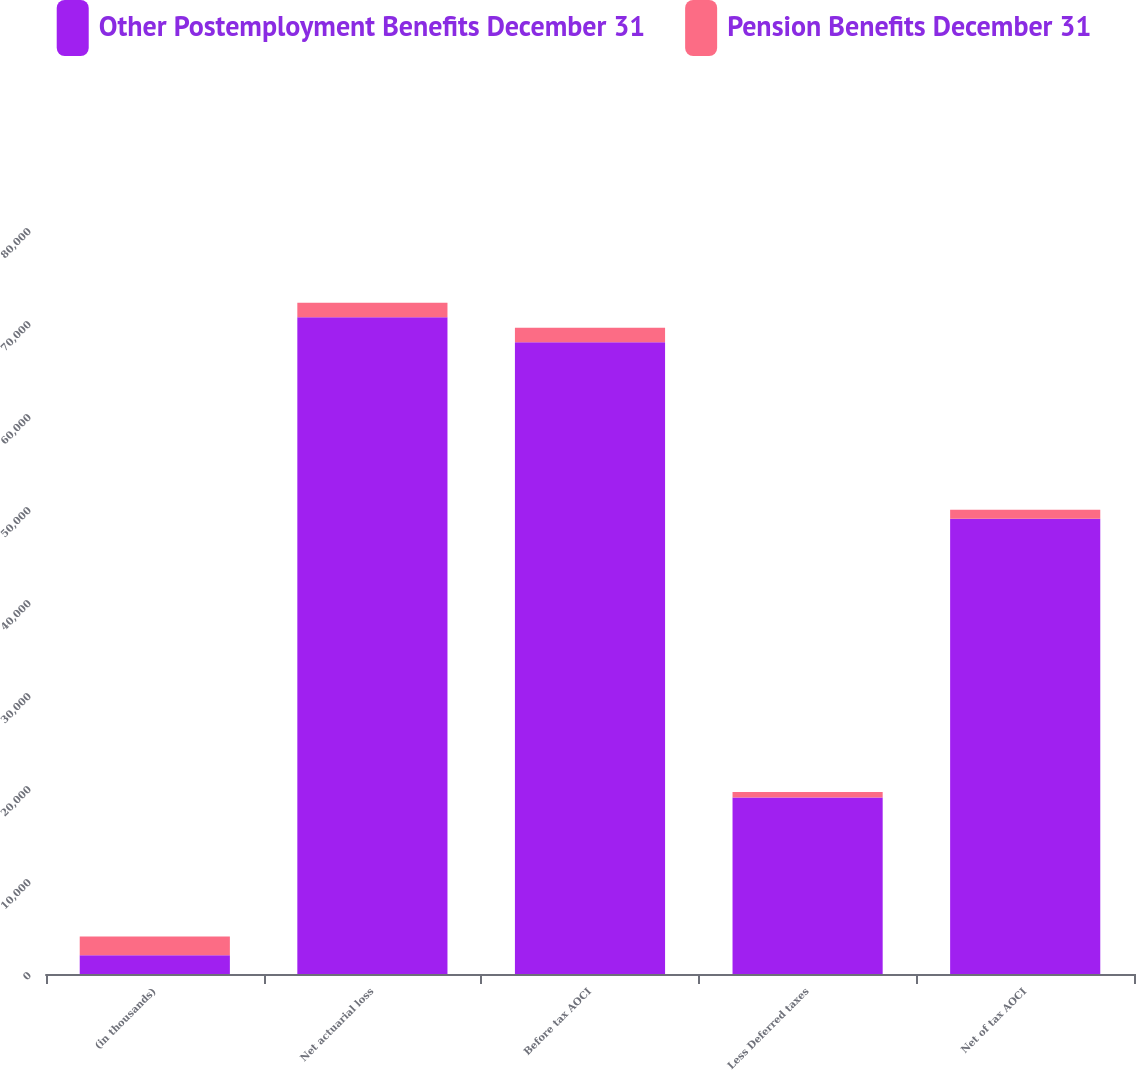Convert chart to OTSL. <chart><loc_0><loc_0><loc_500><loc_500><stacked_bar_chart><ecel><fcel>(in thousands)<fcel>Net actuarial loss<fcel>Before tax AOCI<fcel>Less Deferred taxes<fcel>Net of tax AOCI<nl><fcel>Other Postemployment Benefits December 31<fcel>2013<fcel>70615<fcel>67931<fcel>18974<fcel>48957<nl><fcel>Pension Benefits December 31<fcel>2013<fcel>1557<fcel>1566<fcel>605<fcel>961<nl></chart> 